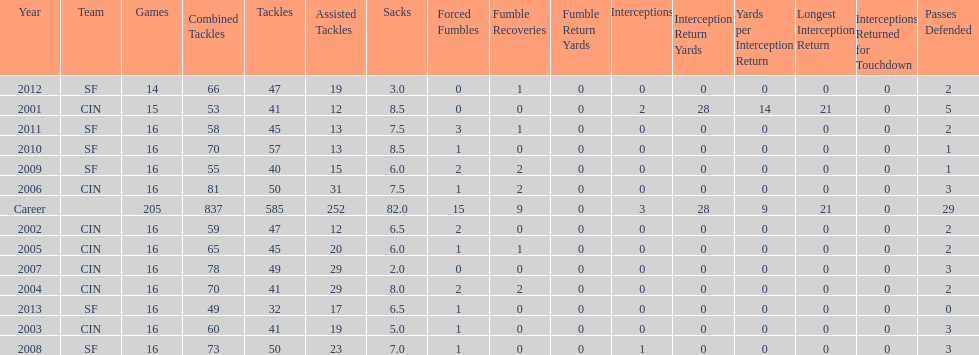How many fumble recoveries did this player have in 2004? 2. 